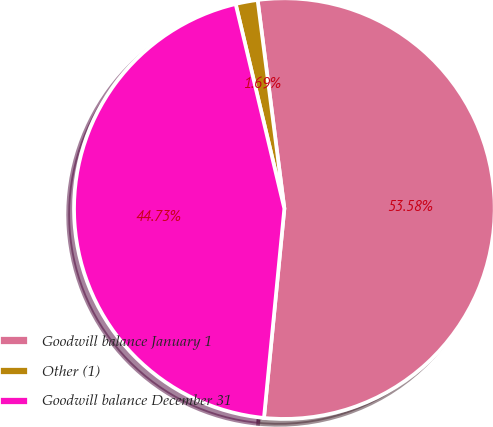Convert chart. <chart><loc_0><loc_0><loc_500><loc_500><pie_chart><fcel>Goodwill balance January 1<fcel>Other (1)<fcel>Goodwill balance December 31<nl><fcel>53.57%<fcel>1.69%<fcel>44.73%<nl></chart> 